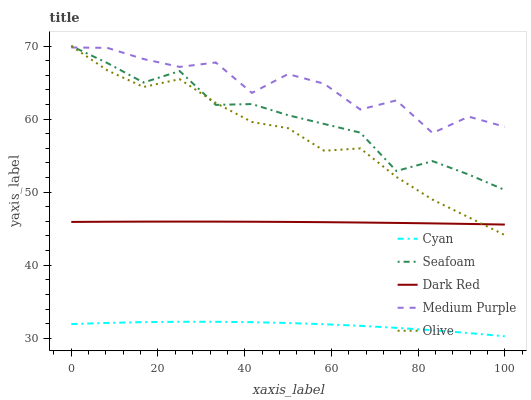Does Cyan have the minimum area under the curve?
Answer yes or no. Yes. Does Medium Purple have the maximum area under the curve?
Answer yes or no. Yes. Does Olive have the minimum area under the curve?
Answer yes or no. No. Does Olive have the maximum area under the curve?
Answer yes or no. No. Is Dark Red the smoothest?
Answer yes or no. Yes. Is Medium Purple the roughest?
Answer yes or no. Yes. Is Cyan the smoothest?
Answer yes or no. No. Is Cyan the roughest?
Answer yes or no. No. Does Olive have the lowest value?
Answer yes or no. No. Does Seafoam have the highest value?
Answer yes or no. Yes. Does Cyan have the highest value?
Answer yes or no. No. Is Cyan less than Dark Red?
Answer yes or no. Yes. Is Olive greater than Cyan?
Answer yes or no. Yes. Does Olive intersect Dark Red?
Answer yes or no. Yes. Is Olive less than Dark Red?
Answer yes or no. No. Is Olive greater than Dark Red?
Answer yes or no. No. Does Cyan intersect Dark Red?
Answer yes or no. No. 